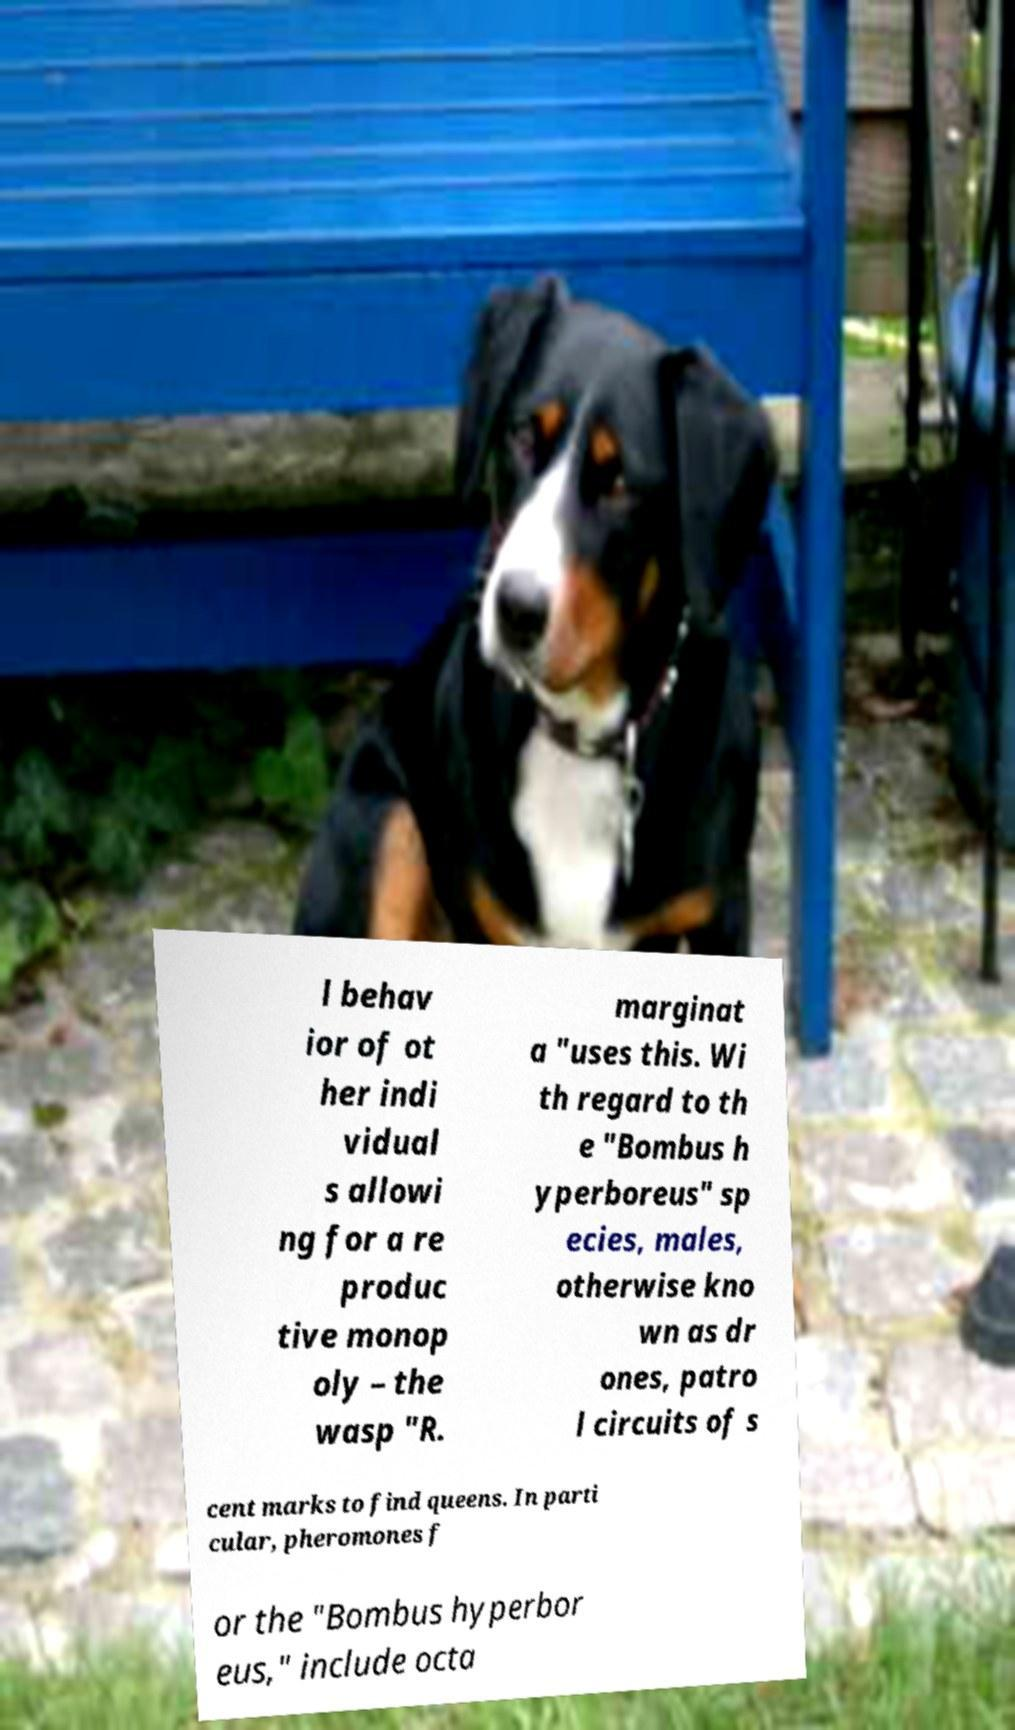There's text embedded in this image that I need extracted. Can you transcribe it verbatim? l behav ior of ot her indi vidual s allowi ng for a re produc tive monop oly – the wasp "R. marginat a "uses this. Wi th regard to th e "Bombus h yperboreus" sp ecies, males, otherwise kno wn as dr ones, patro l circuits of s cent marks to find queens. In parti cular, pheromones f or the "Bombus hyperbor eus," include octa 